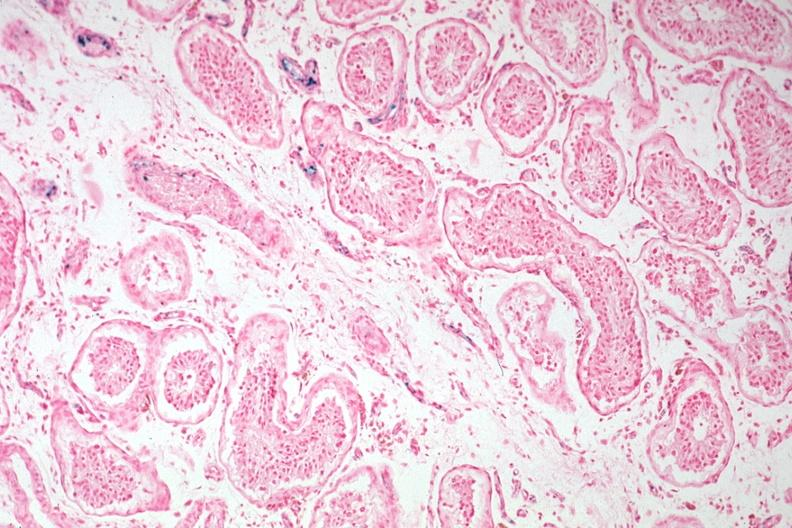what stain tubular atrophy and interstitial iron deposits?
Answer the question using a single word or phrase. Iron 